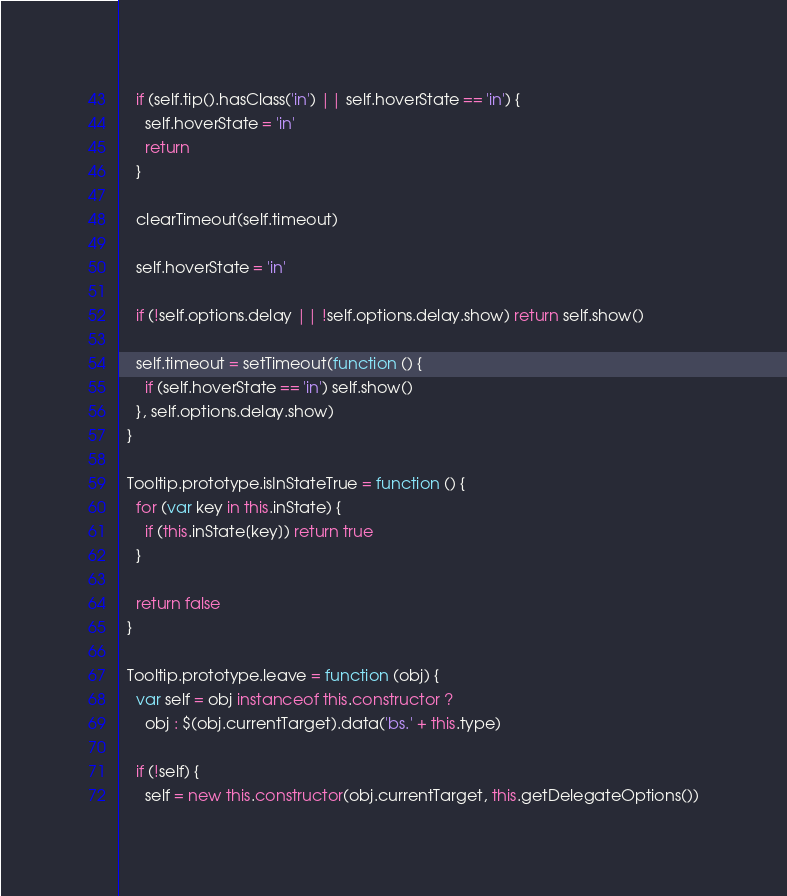<code> <loc_0><loc_0><loc_500><loc_500><_JavaScript_>    if (self.tip().hasClass('in') || self.hoverState == 'in') {
      self.hoverState = 'in'
      return
    }

    clearTimeout(self.timeout)

    self.hoverState = 'in'

    if (!self.options.delay || !self.options.delay.show) return self.show()

    self.timeout = setTimeout(function () {
      if (self.hoverState == 'in') self.show()
    }, self.options.delay.show)
  }

  Tooltip.prototype.isInStateTrue = function () {
    for (var key in this.inState) {
      if (this.inState[key]) return true
    }

    return false
  }

  Tooltip.prototype.leave = function (obj) {
    var self = obj instanceof this.constructor ?
      obj : $(obj.currentTarget).data('bs.' + this.type)

    if (!self) {
      self = new this.constructor(obj.currentTarget, this.getDelegateOptions())</code> 